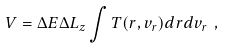<formula> <loc_0><loc_0><loc_500><loc_500>V = \Delta E \Delta L _ { z } \int T ( r , v _ { r } ) d r d v _ { r } \ ,</formula> 